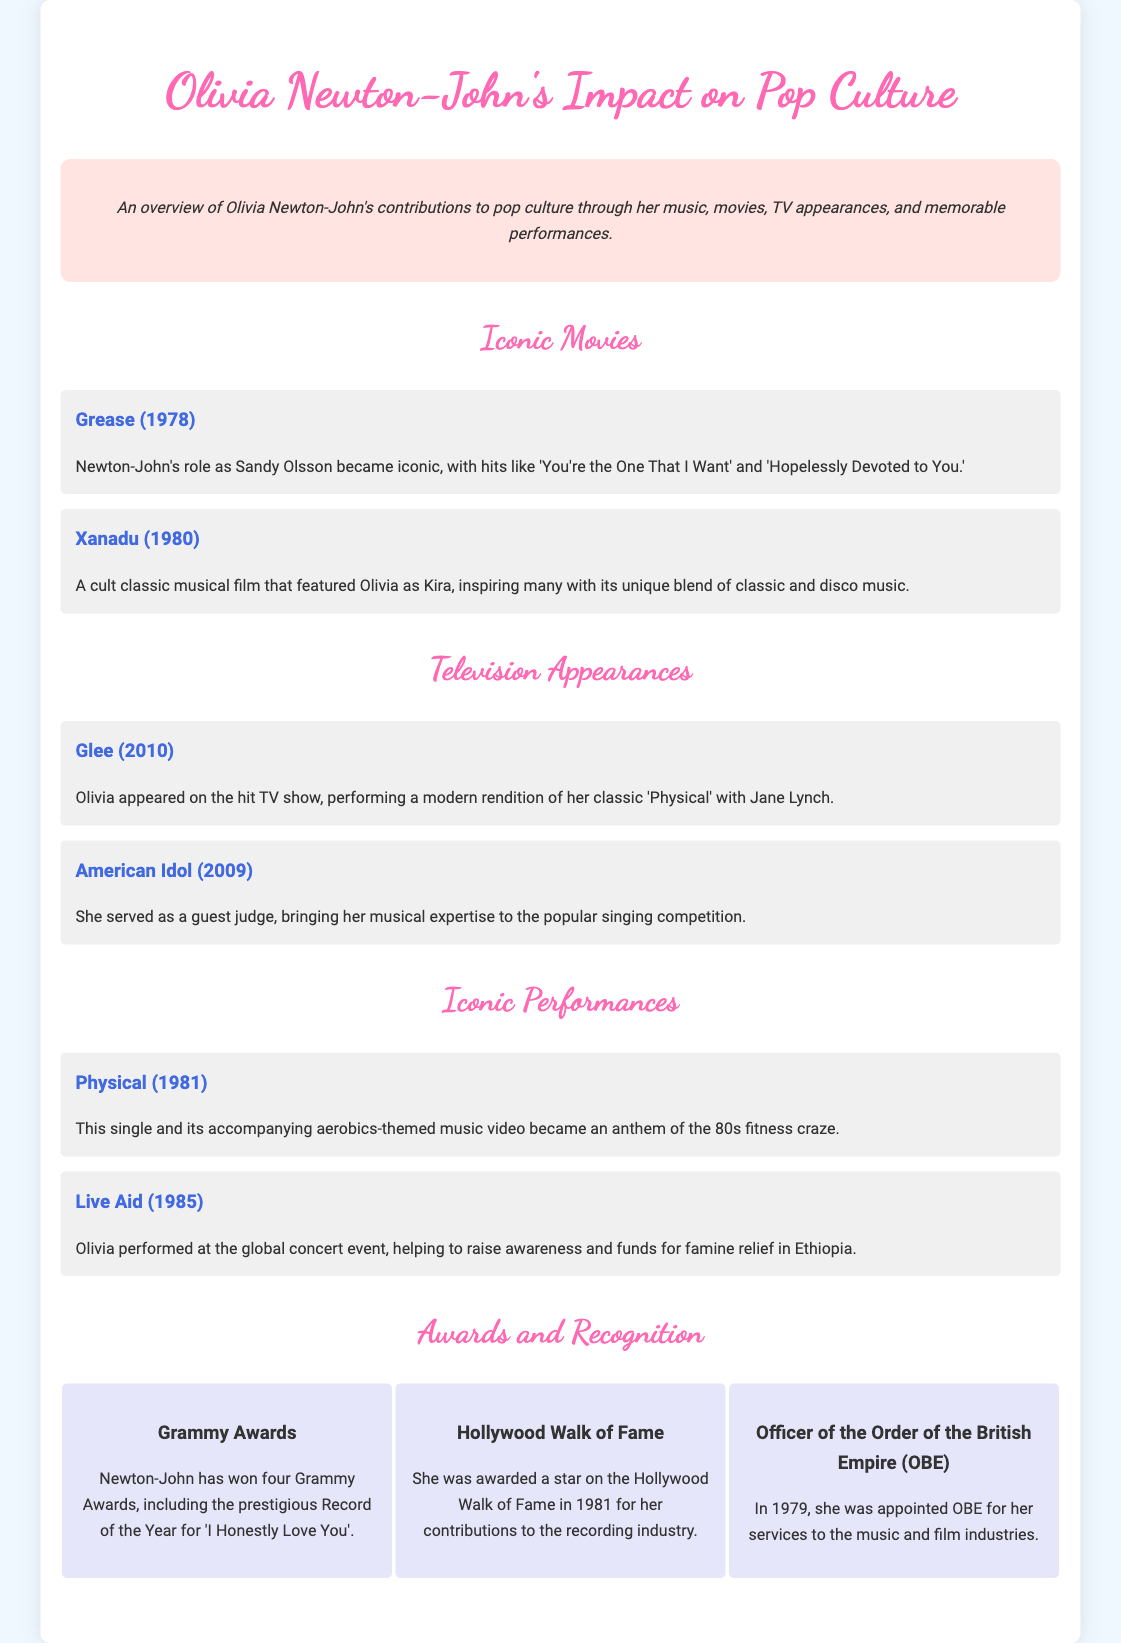What iconic role did Olivia Newton-John play in Grease? Olivia Newton-John played the role of Sandy Olsson in the movie Grease.
Answer: Sandy Olsson What year was Xanadu released? The movie Xanadu was released in 1980.
Answer: 1980 Which TV show featured Olivia performing 'Physical' in 2010? Olivia appeared on Glee in 2010, performing a rendition of 'Physical'.
Answer: Glee How many Grammy Awards has Olivia Newton-John won? Olivia Newton-John has won four Grammy Awards.
Answer: Four What was the significance of Olivia's performance at Live Aid? Her performance at Live Aid helped to raise awareness and funds for famine relief in Ethiopia.
Answer: Famine relief In which year did Olivia Newton-John receive her star on the Hollywood Walk of Fame? Olivia received her star on the Hollywood Walk of Fame in 1981.
Answer: 1981 What unique theme was associated with the music video for 'Physical'? The music video for 'Physical' featured an aerobics theme.
Answer: Aerobics Who did Olivia perform 'Physical' with on Glee? Olivia performed 'Physical' with Jane Lynch on Glee.
Answer: Jane Lynch 